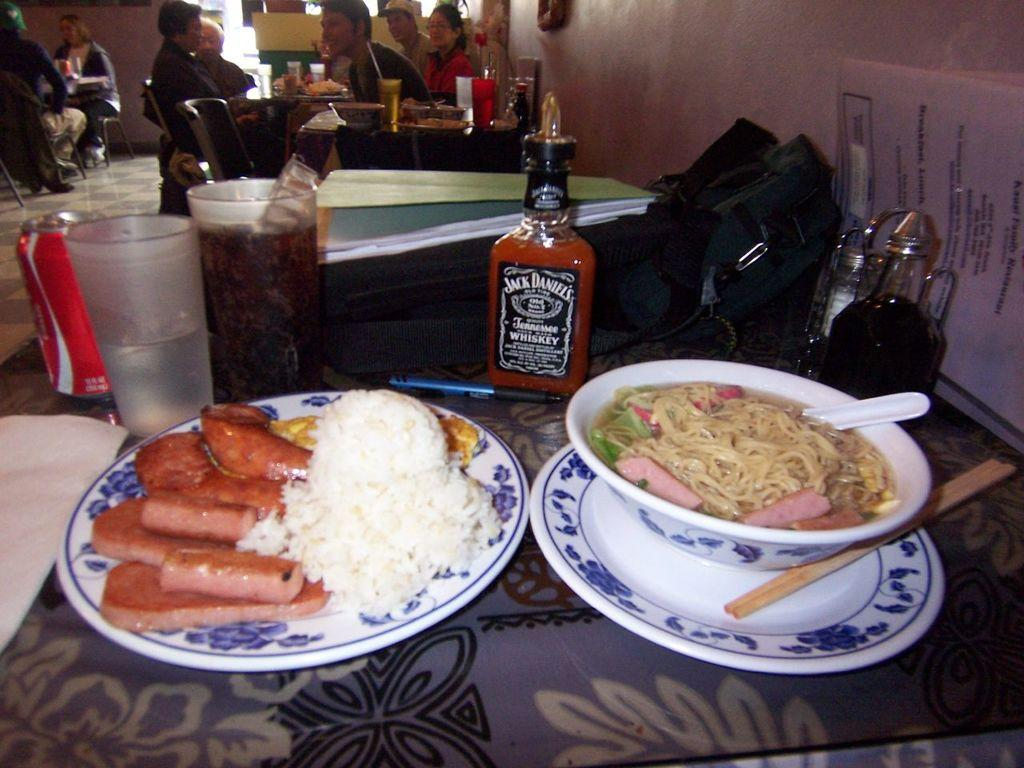What are the people in the image doing? The people in the image are sitting on chairs. What is on the table in the image? There is a plate, food, a glass, a tin, a bottle, a bag, and papers on the table. Can you describe the food on the table? The food on the table is not specified in the facts, so we cannot describe it. What type of scarf is draped over the stew in the image? There is no stew or scarf present in the image. What impulse might have led the people to gather around the table in the image? The facts do not provide information about the people's motivations or impulses for gathering around the table. 